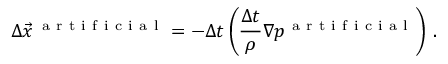<formula> <loc_0><loc_0><loc_500><loc_500>\Delta \vec { x } ^ { \, a r t i f i c i a l } = - \Delta t \left ( \frac { \Delta t } { \rho } \nabla p ^ { a r t i f i c i a l } \right ) \, .</formula> 